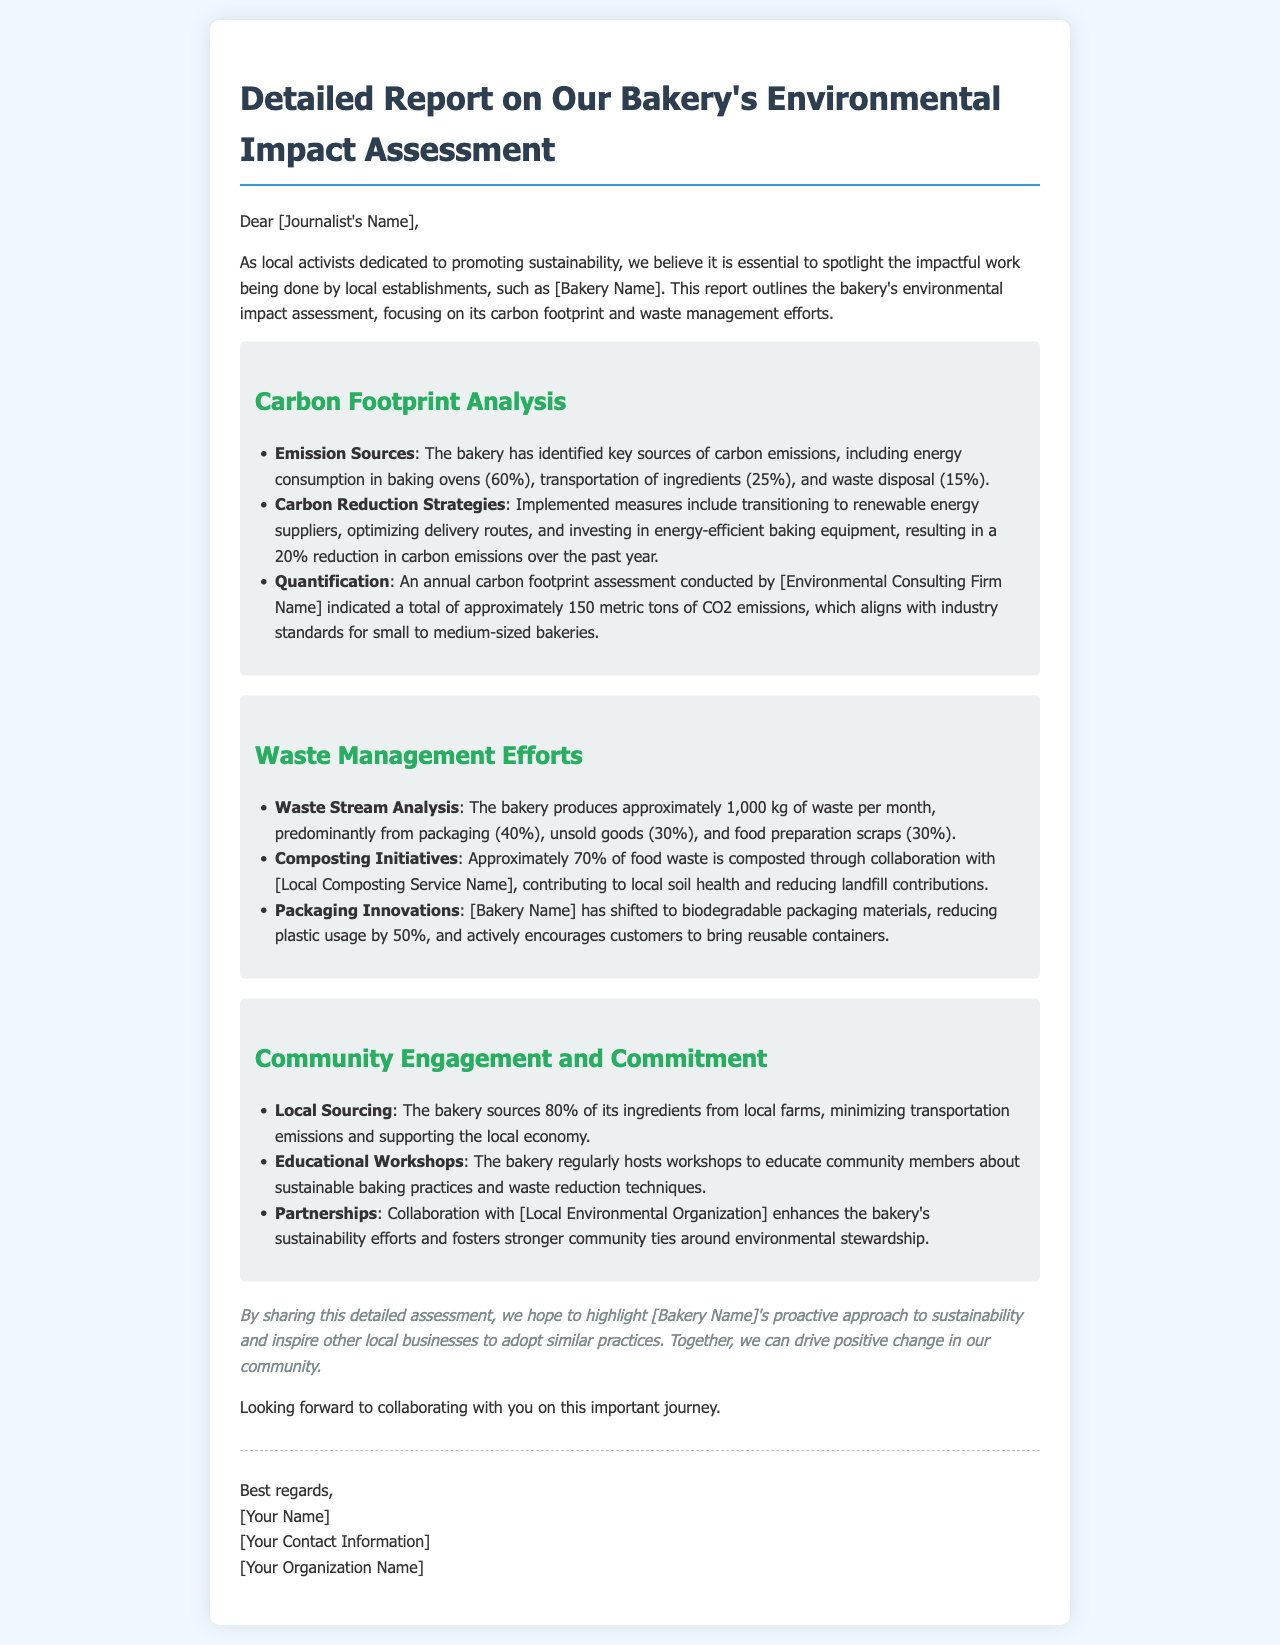What is the bakery's total carbon footprint in metric tons? The total carbon footprint assessment indicated a total of approximately 150 metric tons of CO2 emissions.
Answer: 150 metric tons What percentage of the bakery's waste comes from packaging? The waste stream analysis indicated that packaging accounts for 40% of the bakery's total waste production.
Answer: 40% What is the percentage reduction in carbon emissions over the past year? The bakery has achieved a 20% reduction in carbon emissions through various strategies.
Answer: 20% Which firm conducted the annual carbon footprint assessment? The document mentions that the annual carbon footprint assessment was conducted by an environmental consulting firm, but does not specify the name.
Answer: [Environmental Consulting Firm Name] How much of the food waste is composted? Approximately 70% of the food waste is composted according to the report.
Answer: 70% What is the main source of carbon emissions from baking? The key source of carbon emissions identified is energy consumption in baking ovens, accounting for 60%.
Answer: 60% What innovative packaging materials has the bakery adopted? The bakery has shifted to biodegradable packaging materials, reducing plastic usage by 50%.
Answer: Biodegradable packaging materials What percentage of ingredients does the bakery source locally? The bakery sources 80% of its ingredients from local farms, which supports the local economy and minimizes transportation emissions.
Answer: 80% What type of workshops does the bakery host? The bakery regularly hosts educational workshops to inform community members about sustainable baking practices and waste reduction techniques.
Answer: Educational workshops 